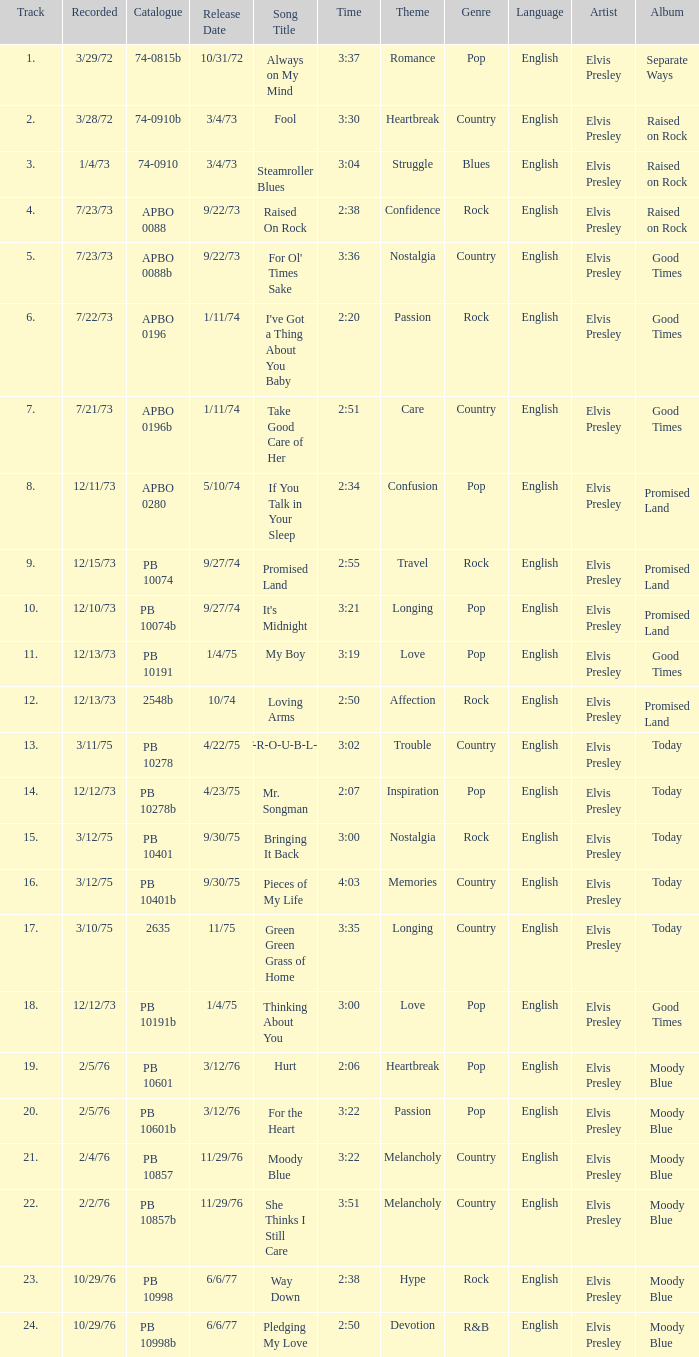Tell me the time for 6/6/77 release date and song title of way down 2:38. Could you help me parse every detail presented in this table? {'header': ['Track', 'Recorded', 'Catalogue', 'Release Date', 'Song Title', 'Time', 'Theme', 'Genre', 'Language', 'Artist', 'Album'], 'rows': [['1.', '3/29/72', '74-0815b', '10/31/72', 'Always on My Mind', '3:37', 'Romance', 'Pop', 'English', 'Elvis Presley', 'Separate Ways'], ['2.', '3/28/72', '74-0910b', '3/4/73', 'Fool', '3:30', 'Heartbreak', 'Country', 'English', 'Elvis Presley', 'Raised on Rock'], ['3.', '1/4/73', '74-0910', '3/4/73', 'Steamroller Blues', '3:04', 'Struggle', 'Blues', 'English', 'Elvis Presley', 'Raised on Rock'], ['4.', '7/23/73', 'APBO 0088', '9/22/73', 'Raised On Rock', '2:38', 'Confidence', 'Rock', 'English', 'Elvis Presley', 'Raised on Rock'], ['5.', '7/23/73', 'APBO 0088b', '9/22/73', "For Ol' Times Sake", '3:36', 'Nostalgia', 'Country', 'English', 'Elvis Presley', 'Good Times'], ['6.', '7/22/73', 'APBO 0196', '1/11/74', "I've Got a Thing About You Baby", '2:20', 'Passion', 'Rock', 'English', 'Elvis Presley', 'Good Times'], ['7.', '7/21/73', 'APBO 0196b', '1/11/74', 'Take Good Care of Her', '2:51', 'Care', 'Country', 'English', 'Elvis Presley', 'Good Times'], ['8.', '12/11/73', 'APBO 0280', '5/10/74', 'If You Talk in Your Sleep', '2:34', 'Confusion', 'Pop', 'English', 'Elvis Presley', 'Promised Land'], ['9.', '12/15/73', 'PB 10074', '9/27/74', 'Promised Land', '2:55', 'Travel', 'Rock', 'English', 'Elvis Presley', 'Promised Land'], ['10.', '12/10/73', 'PB 10074b', '9/27/74', "It's Midnight", '3:21', 'Longing', 'Pop', 'English', 'Elvis Presley', 'Promised Land'], ['11.', '12/13/73', 'PB 10191', '1/4/75', 'My Boy', '3:19', 'Love', 'Pop', 'English', 'Elvis Presley', 'Good Times'], ['12.', '12/13/73', '2548b', '10/74', 'Loving Arms', '2:50', 'Affection', 'Rock', 'English', 'Elvis Presley', 'Promised Land'], ['13.', '3/11/75', 'PB 10278', '4/22/75', 'T-R-O-U-B-L-E', '3:02', 'Trouble', 'Country', 'English', 'Elvis Presley', 'Today'], ['14.', '12/12/73', 'PB 10278b', '4/23/75', 'Mr. Songman', '2:07', 'Inspiration', 'Pop', 'English', 'Elvis Presley', 'Today'], ['15.', '3/12/75', 'PB 10401', '9/30/75', 'Bringing It Back', '3:00', 'Nostalgia', 'Rock', 'English', 'Elvis Presley', 'Today'], ['16.', '3/12/75', 'PB 10401b', '9/30/75', 'Pieces of My Life', '4:03', 'Memories', 'Country', 'English', 'Elvis Presley', 'Today'], ['17.', '3/10/75', '2635', '11/75', 'Green Green Grass of Home', '3:35', 'Longing', 'Country', 'English', 'Elvis Presley', 'Today'], ['18.', '12/12/73', 'PB 10191b', '1/4/75', 'Thinking About You', '3:00', 'Love', 'Pop', 'English', 'Elvis Presley', 'Good Times'], ['19.', '2/5/76', 'PB 10601', '3/12/76', 'Hurt', '2:06', 'Heartbreak', 'Pop', 'English', 'Elvis Presley', 'Moody Blue'], ['20.', '2/5/76', 'PB 10601b', '3/12/76', 'For the Heart', '3:22', 'Passion', 'Pop', 'English', 'Elvis Presley', 'Moody Blue'], ['21.', '2/4/76', 'PB 10857', '11/29/76', 'Moody Blue', '3:22', 'Melancholy', 'Country', 'English', 'Elvis Presley', 'Moody Blue'], ['22.', '2/2/76', 'PB 10857b', '11/29/76', 'She Thinks I Still Care', '3:51', 'Melancholy', 'Country', 'English', 'Elvis Presley', 'Moody Blue'], ['23.', '10/29/76', 'PB 10998', '6/6/77', 'Way Down', '2:38', 'Hype', 'Rock', 'English', 'Elvis Presley', 'Moody Blue'], ['24.', '10/29/76', 'PB 10998b', '6/6/77', 'Pledging My Love', '2:50', 'Devotion', 'R&B', 'English', 'Elvis Presley', 'Moody Blue']]} 